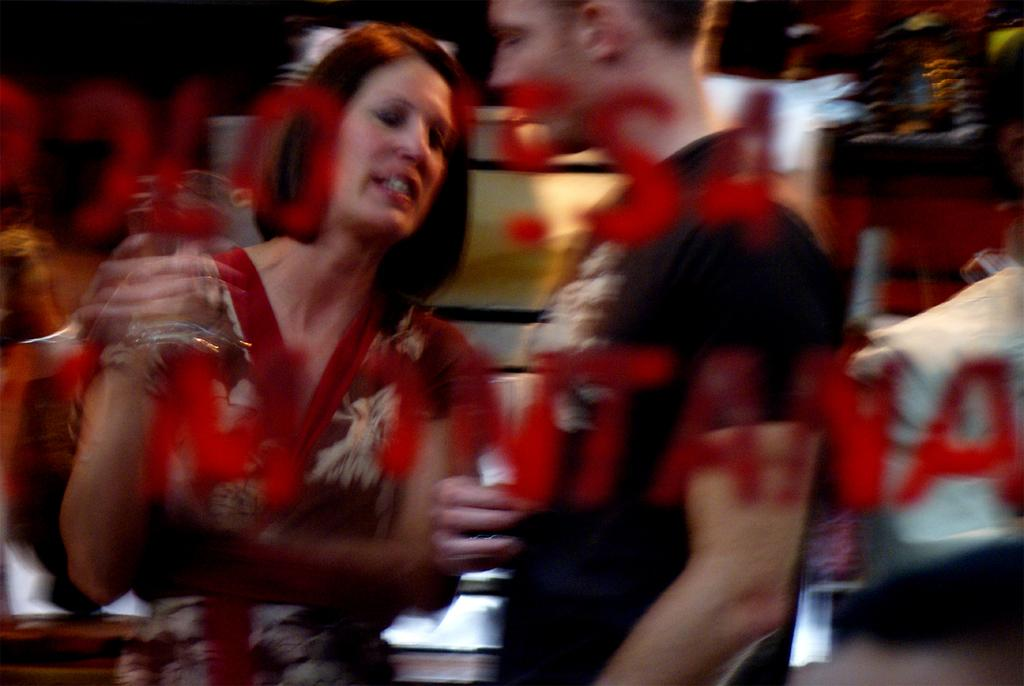What is the main subject of the image? The main subject of the image is persons standing in the middle of the image. Can you describe the background of the image? There are objects in the background of the image. What type of grandmother can be seen in the image? There is no grandmother present in the image. How many trains are visible in the image? There are no trains visible in the image. 